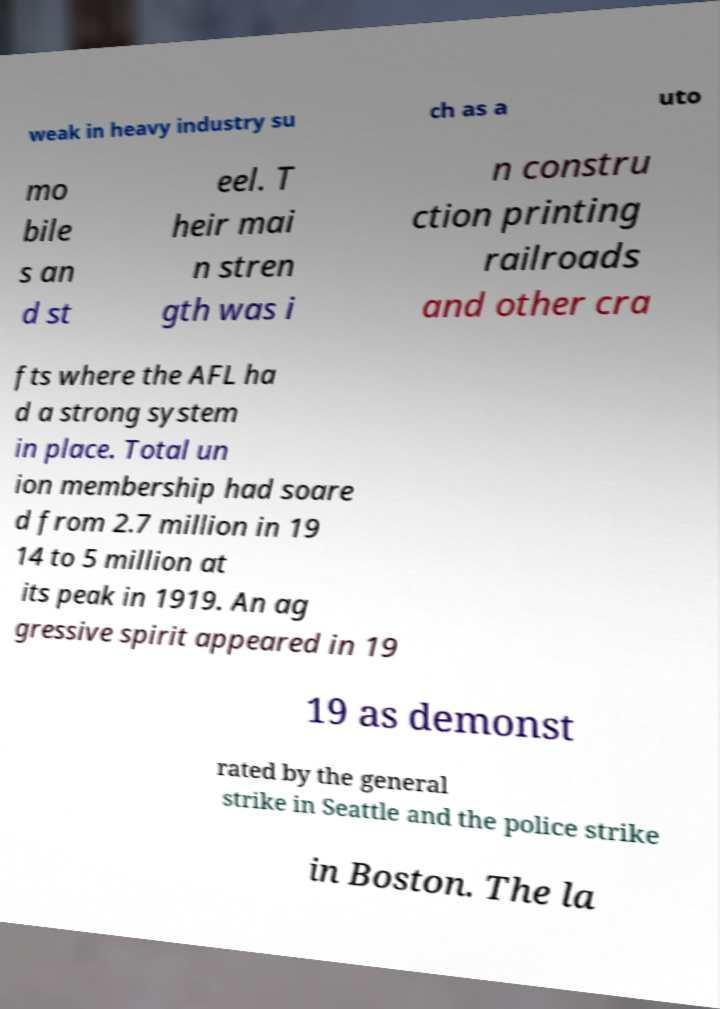I need the written content from this picture converted into text. Can you do that? weak in heavy industry su ch as a uto mo bile s an d st eel. T heir mai n stren gth was i n constru ction printing railroads and other cra fts where the AFL ha d a strong system in place. Total un ion membership had soare d from 2.7 million in 19 14 to 5 million at its peak in 1919. An ag gressive spirit appeared in 19 19 as demonst rated by the general strike in Seattle and the police strike in Boston. The la 